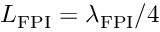Convert formula to latex. <formula><loc_0><loc_0><loc_500><loc_500>L _ { F P I } = \lambda _ { F P I } / 4</formula> 